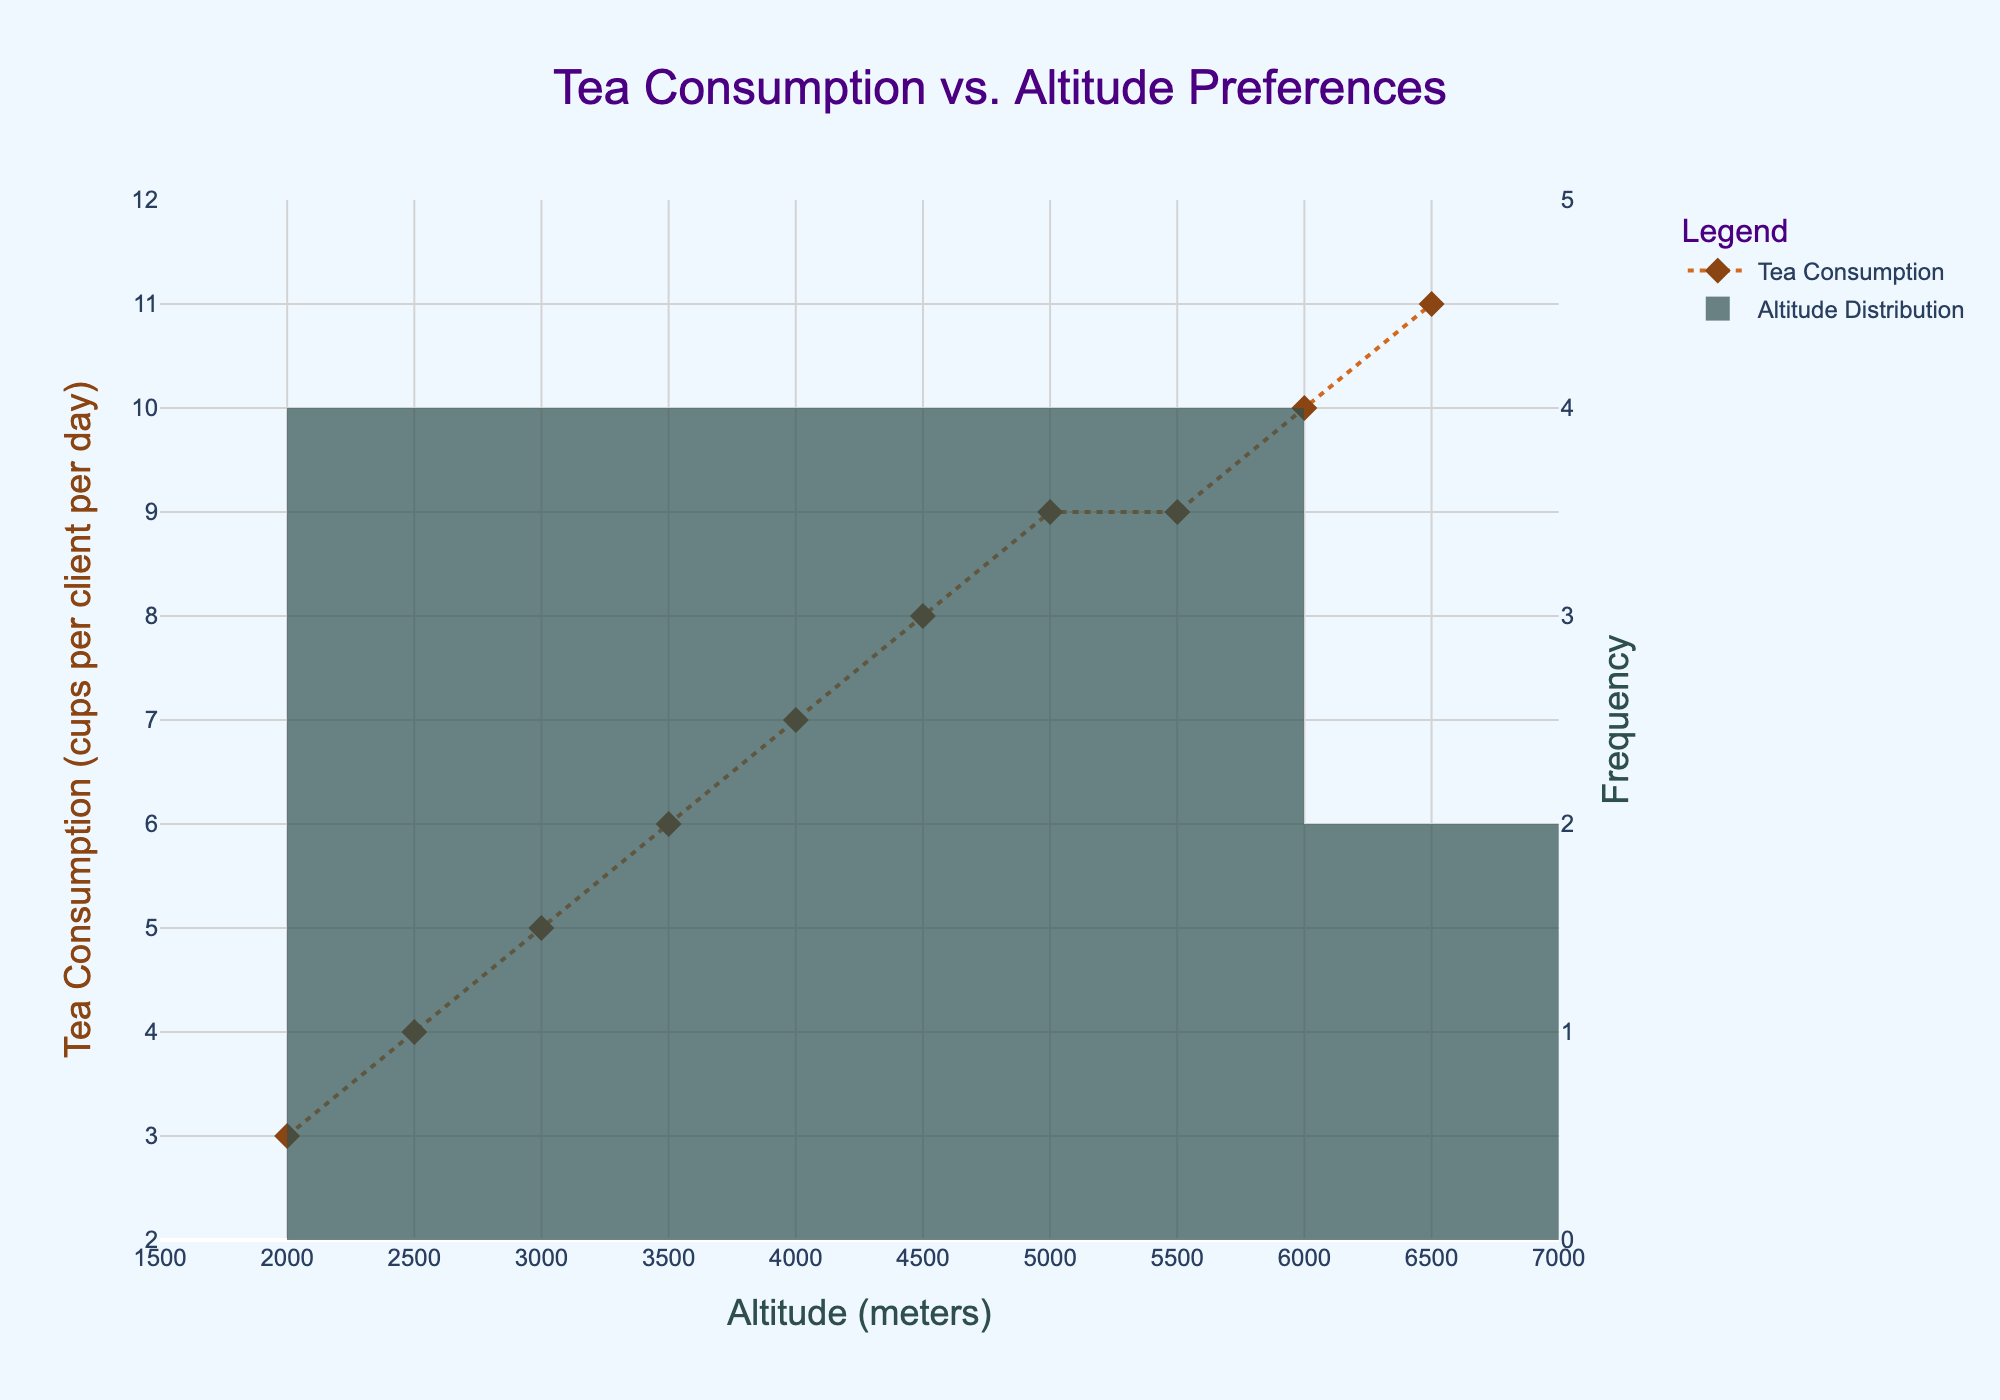What is the title of the figure? The title is usually at the top of the figure and is used to summarize the content. Here, the title is in large text and centered.
Answer: Tea Consumption vs. Altitude Preferences What are the units used for altitude on the x-axis? The units are displayed along the axis, along with the axis title. Here, "Altitude (meters)" is labeled on the x-axis.
Answer: Meters At what altitude is tea consumption highest based on the plot? To find the highest tea consumption, look for the highest point on the 'Tea Consumption' line plot. The corresponding x-axis value gives the altitude.
Answer: 6500 meters What is the frequency range (y-axis) for altitude distribution? The frequency range can be found by looking at the y-axis on the right side of the figure, which is labeled 'Frequency'. This axis ranges from 0 to 5.
Answer: 0 to 5 How many cups of tea are consumed at 4000 meters altitude? Identify the altitude 4000 meters on the x-axis and trace it to the corresponding point on the 'Tea Consumption' line plot to see the y-value.
Answer: 7 cups Is there a trend between altitude and tea consumption? To identify the trend, observe if the tea consumption increases, decreases, or remains stable as the altitude changes. Here, tea consumption steadily increases with altitude.
Answer: Yes, it increases Are there any altitudes where the tea consumption is the same? Check the 'Tea Consumption' line plot for any horizontal lines or equal y-values at different x-axis points.
Answer: Yes, at 5000 and 5500 meters Which altitude range has the most significant distribution based on the histogram bars? Look at the height of the bars in the histogram on the plot to find the range with the highest bar.
Answer: 3000 to 4000 meters Calculate the average tea consumption at altitudes 2000, 4000, and 6000 meters. To find the average, sum the tea consumption values at these altitudes and divide by the number of altitudes. (3+7+10)/3 = 20/3
Answer: Approx. 6.67 cups Compare the tea consumption between altitudes 3000 meters and 6000 meters. Find the tea consumption values at 3000 meters and 6000 meters on the line plot and compare them.
Answer: 5 cups (3000 meters) < 10 cups (6000 meters) 